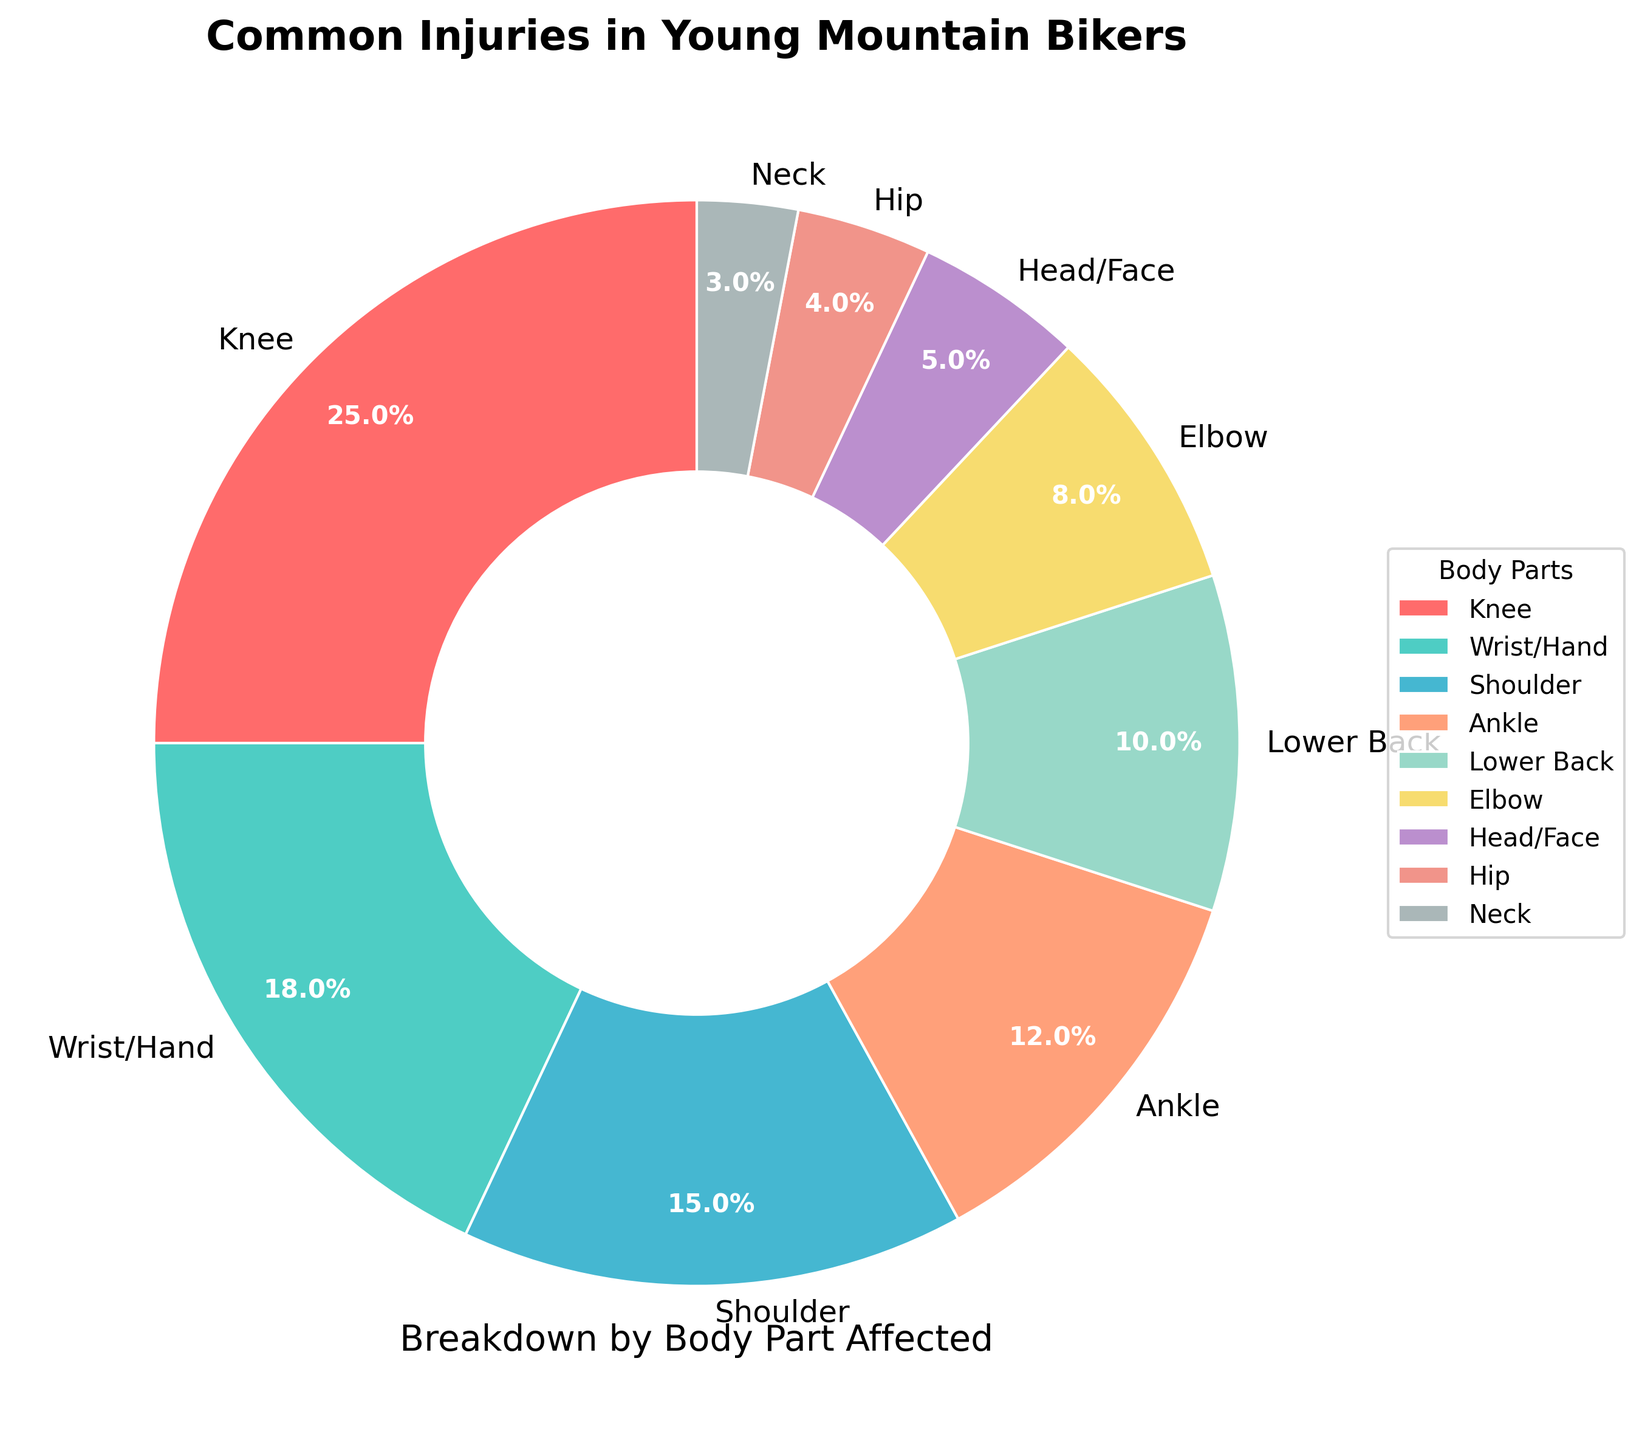Which body part is most frequently injured? The most frequently injured body part is represented by the largest section of the pie chart.
Answer: Knee What is the percentage of injuries that affect the wrist/hand? By looking at the section of the pie chart labeled "Wrist/Hand," you can see the percentage noted.
Answer: 18% Which injuries are less common than elbow injuries? Identify the percentages of injuries for all body parts and compare them to the elbow's 8% to find the smaller values.
Answer: Head/Face, Hip, Neck How much greater is the percentage of knee injuries compared to neck injuries? Subtract the percentage of neck injuries (3%) from the percentage of knee injuries (25%).
Answer: 22% What is the combined percentage of injuries affecting the lower back, elbow, and head/face? Add the percentages of lower back (10%), elbow (8%), and head/face (5%) together.
Answer: 23% Rank the injuries from most common to least common. Arrange the injuries according to their percentages in descending order, starting with the highest.
Answer: Knee, Wrist/Hand, Shoulder, Ankle, Lower Back, Elbow, Head/Face, Hip, Neck Which color represents the shoulder injuries on the pie chart? Identify the color of the section of the pie chart labeled "Shoulder."
Answer: Blue Are ankle injuries more common than hip injuries? Compare the percentage of ankle injuries (12%) with hip injuries (4%).
Answer: Yes What part of the body has injuries that are closest in percentage to shoulder injuries? Look at the percentages on the pie chart and find the one closest to the shoulder injuries' 15%.
Answer: Ankle If you combine the percentages of knee and wrist/hand injuries, what fraction of the total injuries do they represent? Add the percentages of knee (25%) and wrist/hand (18%) injuries to get 43%, then convert this to a fraction.
Answer: 43% 